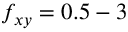<formula> <loc_0><loc_0><loc_500><loc_500>f _ { x y } = 0 . 5 - 3</formula> 